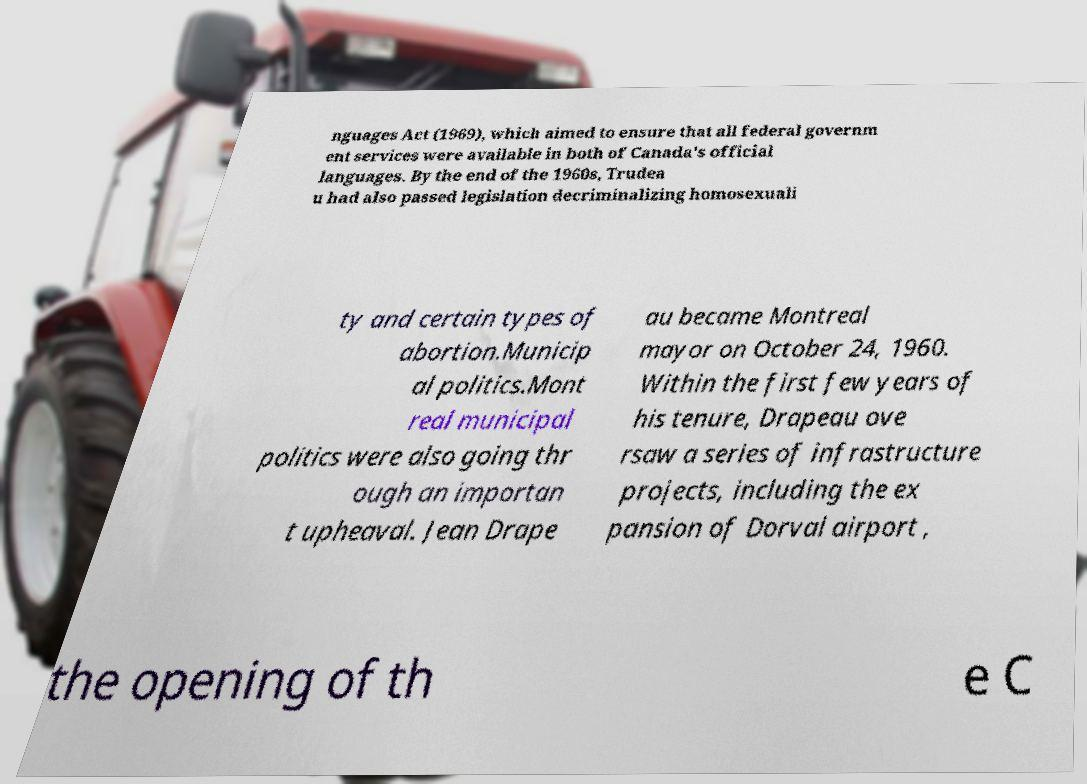Please identify and transcribe the text found in this image. nguages Act (1969), which aimed to ensure that all federal governm ent services were available in both of Canada's official languages. By the end of the 1960s, Trudea u had also passed legislation decriminalizing homosexuali ty and certain types of abortion.Municip al politics.Mont real municipal politics were also going thr ough an importan t upheaval. Jean Drape au became Montreal mayor on October 24, 1960. Within the first few years of his tenure, Drapeau ove rsaw a series of infrastructure projects, including the ex pansion of Dorval airport , the opening of th e C 